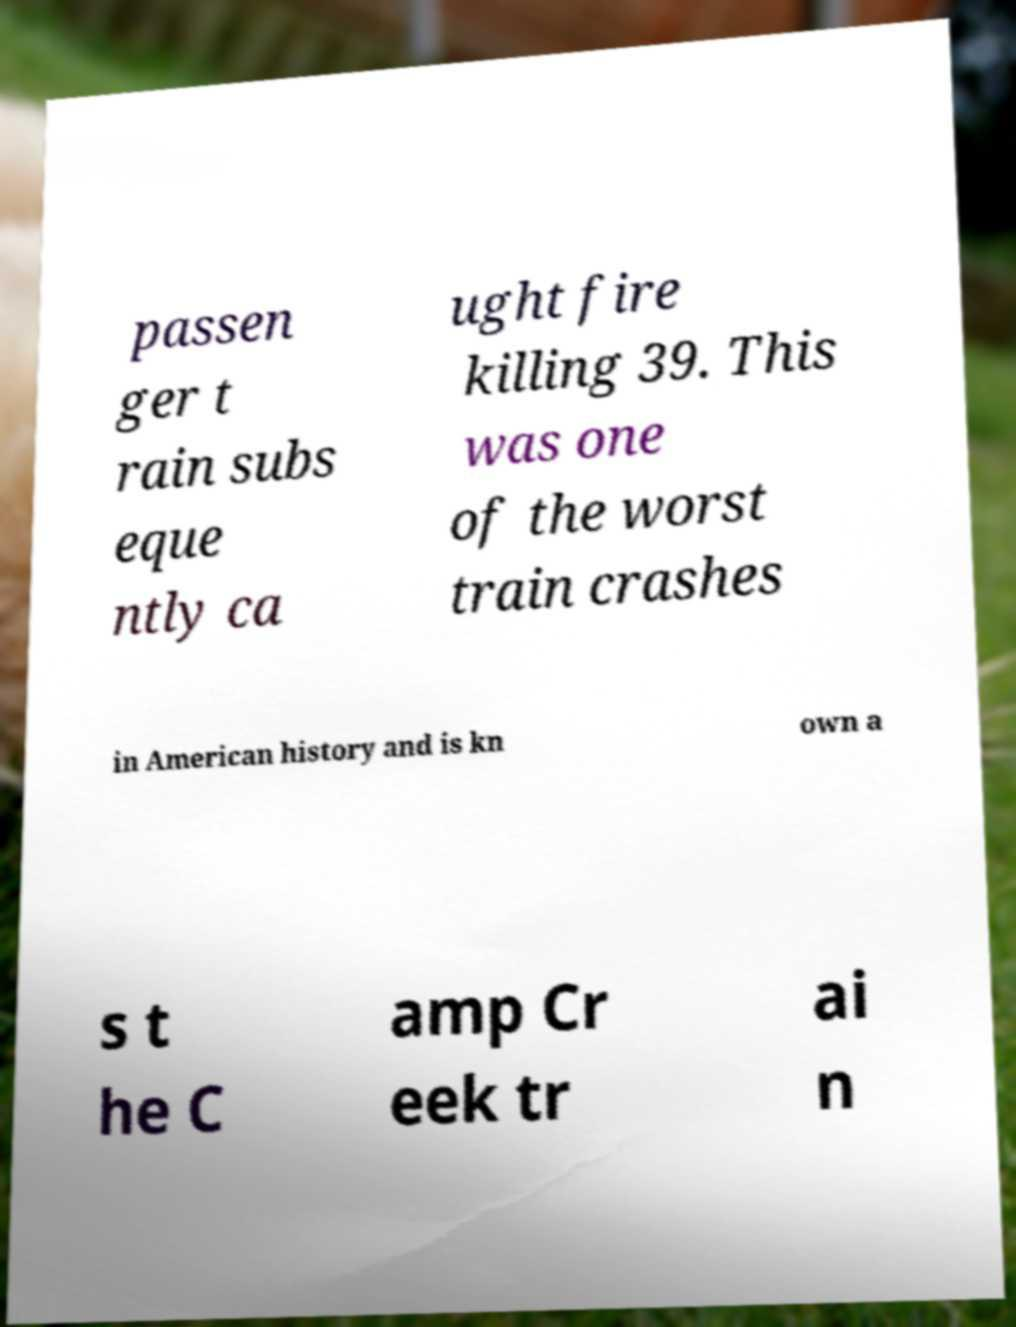What messages or text are displayed in this image? I need them in a readable, typed format. passen ger t rain subs eque ntly ca ught fire killing 39. This was one of the worst train crashes in American history and is kn own a s t he C amp Cr eek tr ai n 